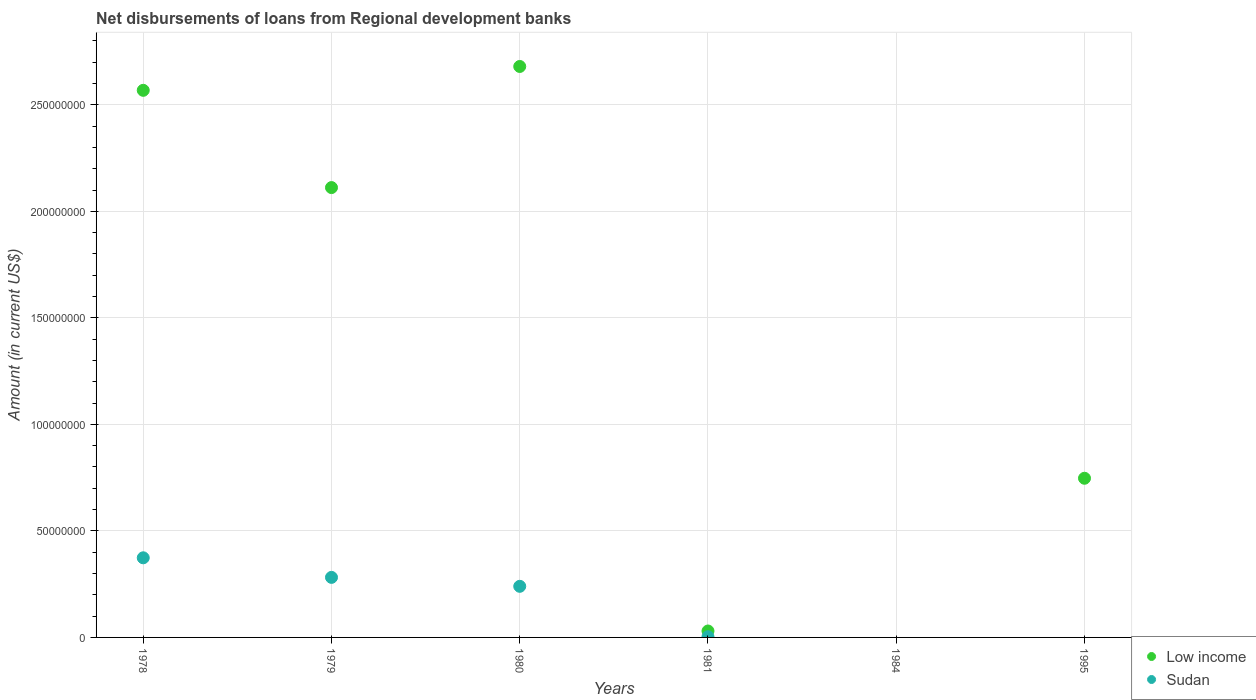What is the amount of disbursements of loans from regional development banks in Sudan in 1979?
Your answer should be very brief. 2.82e+07. Across all years, what is the maximum amount of disbursements of loans from regional development banks in Low income?
Make the answer very short. 2.68e+08. What is the total amount of disbursements of loans from regional development banks in Low income in the graph?
Provide a short and direct response. 8.14e+08. What is the difference between the amount of disbursements of loans from regional development banks in Sudan in 1979 and that in 1981?
Make the answer very short. 2.79e+07. What is the difference between the amount of disbursements of loans from regional development banks in Sudan in 1995 and the amount of disbursements of loans from regional development banks in Low income in 1980?
Provide a short and direct response. -2.68e+08. What is the average amount of disbursements of loans from regional development banks in Sudan per year?
Your answer should be compact. 1.50e+07. In the year 1981, what is the difference between the amount of disbursements of loans from regional development banks in Low income and amount of disbursements of loans from regional development banks in Sudan?
Offer a terse response. 2.70e+06. What is the ratio of the amount of disbursements of loans from regional development banks in Low income in 1979 to that in 1995?
Offer a very short reply. 2.83. What is the difference between the highest and the second highest amount of disbursements of loans from regional development banks in Low income?
Make the answer very short. 1.12e+07. What is the difference between the highest and the lowest amount of disbursements of loans from regional development banks in Sudan?
Make the answer very short. 3.74e+07. How many dotlines are there?
Your answer should be compact. 2. How many years are there in the graph?
Provide a short and direct response. 6. What is the difference between two consecutive major ticks on the Y-axis?
Ensure brevity in your answer.  5.00e+07. Does the graph contain any zero values?
Offer a very short reply. Yes. Does the graph contain grids?
Keep it short and to the point. Yes. Where does the legend appear in the graph?
Provide a succinct answer. Bottom right. How many legend labels are there?
Provide a succinct answer. 2. What is the title of the graph?
Offer a very short reply. Net disbursements of loans from Regional development banks. What is the label or title of the X-axis?
Offer a terse response. Years. What is the label or title of the Y-axis?
Your answer should be very brief. Amount (in current US$). What is the Amount (in current US$) in Low income in 1978?
Keep it short and to the point. 2.57e+08. What is the Amount (in current US$) in Sudan in 1978?
Your answer should be compact. 3.74e+07. What is the Amount (in current US$) in Low income in 1979?
Your answer should be very brief. 2.11e+08. What is the Amount (in current US$) in Sudan in 1979?
Provide a short and direct response. 2.82e+07. What is the Amount (in current US$) in Low income in 1980?
Provide a short and direct response. 2.68e+08. What is the Amount (in current US$) in Sudan in 1980?
Provide a short and direct response. 2.40e+07. What is the Amount (in current US$) of Low income in 1981?
Give a very brief answer. 3.02e+06. What is the Amount (in current US$) of Sudan in 1981?
Offer a terse response. 3.20e+05. What is the Amount (in current US$) in Low income in 1984?
Your response must be concise. 0. What is the Amount (in current US$) of Low income in 1995?
Your response must be concise. 7.47e+07. What is the Amount (in current US$) in Sudan in 1995?
Keep it short and to the point. 0. Across all years, what is the maximum Amount (in current US$) in Low income?
Offer a terse response. 2.68e+08. Across all years, what is the maximum Amount (in current US$) of Sudan?
Make the answer very short. 3.74e+07. Across all years, what is the minimum Amount (in current US$) of Low income?
Your answer should be very brief. 0. What is the total Amount (in current US$) of Low income in the graph?
Offer a very short reply. 8.14e+08. What is the total Amount (in current US$) in Sudan in the graph?
Offer a very short reply. 8.99e+07. What is the difference between the Amount (in current US$) of Low income in 1978 and that in 1979?
Give a very brief answer. 4.57e+07. What is the difference between the Amount (in current US$) in Sudan in 1978 and that in 1979?
Give a very brief answer. 9.19e+06. What is the difference between the Amount (in current US$) of Low income in 1978 and that in 1980?
Offer a terse response. -1.12e+07. What is the difference between the Amount (in current US$) in Sudan in 1978 and that in 1980?
Provide a short and direct response. 1.34e+07. What is the difference between the Amount (in current US$) of Low income in 1978 and that in 1981?
Make the answer very short. 2.54e+08. What is the difference between the Amount (in current US$) in Sudan in 1978 and that in 1981?
Ensure brevity in your answer.  3.71e+07. What is the difference between the Amount (in current US$) in Low income in 1978 and that in 1995?
Make the answer very short. 1.82e+08. What is the difference between the Amount (in current US$) in Low income in 1979 and that in 1980?
Make the answer very short. -5.68e+07. What is the difference between the Amount (in current US$) in Sudan in 1979 and that in 1980?
Ensure brevity in your answer.  4.20e+06. What is the difference between the Amount (in current US$) in Low income in 1979 and that in 1981?
Make the answer very short. 2.08e+08. What is the difference between the Amount (in current US$) of Sudan in 1979 and that in 1981?
Your response must be concise. 2.79e+07. What is the difference between the Amount (in current US$) of Low income in 1979 and that in 1995?
Your answer should be compact. 1.36e+08. What is the difference between the Amount (in current US$) of Low income in 1980 and that in 1981?
Offer a very short reply. 2.65e+08. What is the difference between the Amount (in current US$) in Sudan in 1980 and that in 1981?
Offer a terse response. 2.37e+07. What is the difference between the Amount (in current US$) in Low income in 1980 and that in 1995?
Make the answer very short. 1.93e+08. What is the difference between the Amount (in current US$) of Low income in 1981 and that in 1995?
Make the answer very short. -7.17e+07. What is the difference between the Amount (in current US$) of Low income in 1978 and the Amount (in current US$) of Sudan in 1979?
Ensure brevity in your answer.  2.29e+08. What is the difference between the Amount (in current US$) of Low income in 1978 and the Amount (in current US$) of Sudan in 1980?
Ensure brevity in your answer.  2.33e+08. What is the difference between the Amount (in current US$) of Low income in 1978 and the Amount (in current US$) of Sudan in 1981?
Provide a succinct answer. 2.56e+08. What is the difference between the Amount (in current US$) of Low income in 1979 and the Amount (in current US$) of Sudan in 1980?
Your answer should be very brief. 1.87e+08. What is the difference between the Amount (in current US$) of Low income in 1979 and the Amount (in current US$) of Sudan in 1981?
Your response must be concise. 2.11e+08. What is the difference between the Amount (in current US$) in Low income in 1980 and the Amount (in current US$) in Sudan in 1981?
Your response must be concise. 2.68e+08. What is the average Amount (in current US$) in Low income per year?
Your answer should be compact. 1.36e+08. What is the average Amount (in current US$) in Sudan per year?
Provide a short and direct response. 1.50e+07. In the year 1978, what is the difference between the Amount (in current US$) in Low income and Amount (in current US$) in Sudan?
Give a very brief answer. 2.19e+08. In the year 1979, what is the difference between the Amount (in current US$) of Low income and Amount (in current US$) of Sudan?
Ensure brevity in your answer.  1.83e+08. In the year 1980, what is the difference between the Amount (in current US$) of Low income and Amount (in current US$) of Sudan?
Ensure brevity in your answer.  2.44e+08. In the year 1981, what is the difference between the Amount (in current US$) in Low income and Amount (in current US$) in Sudan?
Give a very brief answer. 2.70e+06. What is the ratio of the Amount (in current US$) in Low income in 1978 to that in 1979?
Give a very brief answer. 1.22. What is the ratio of the Amount (in current US$) of Sudan in 1978 to that in 1979?
Your answer should be very brief. 1.33. What is the ratio of the Amount (in current US$) of Low income in 1978 to that in 1980?
Keep it short and to the point. 0.96. What is the ratio of the Amount (in current US$) in Sudan in 1978 to that in 1980?
Your response must be concise. 1.56. What is the ratio of the Amount (in current US$) of Low income in 1978 to that in 1981?
Provide a succinct answer. 85.12. What is the ratio of the Amount (in current US$) in Sudan in 1978 to that in 1981?
Provide a succinct answer. 116.79. What is the ratio of the Amount (in current US$) of Low income in 1978 to that in 1995?
Your answer should be compact. 3.44. What is the ratio of the Amount (in current US$) in Low income in 1979 to that in 1980?
Make the answer very short. 0.79. What is the ratio of the Amount (in current US$) of Sudan in 1979 to that in 1980?
Your answer should be very brief. 1.17. What is the ratio of the Amount (in current US$) in Low income in 1979 to that in 1981?
Your response must be concise. 69.99. What is the ratio of the Amount (in current US$) in Sudan in 1979 to that in 1981?
Give a very brief answer. 88.08. What is the ratio of the Amount (in current US$) of Low income in 1979 to that in 1995?
Ensure brevity in your answer.  2.83. What is the ratio of the Amount (in current US$) of Low income in 1980 to that in 1981?
Your response must be concise. 88.83. What is the ratio of the Amount (in current US$) in Sudan in 1980 to that in 1981?
Keep it short and to the point. 74.97. What is the ratio of the Amount (in current US$) of Low income in 1980 to that in 1995?
Make the answer very short. 3.59. What is the ratio of the Amount (in current US$) of Low income in 1981 to that in 1995?
Offer a terse response. 0.04. What is the difference between the highest and the second highest Amount (in current US$) of Low income?
Offer a terse response. 1.12e+07. What is the difference between the highest and the second highest Amount (in current US$) in Sudan?
Provide a short and direct response. 9.19e+06. What is the difference between the highest and the lowest Amount (in current US$) of Low income?
Offer a terse response. 2.68e+08. What is the difference between the highest and the lowest Amount (in current US$) in Sudan?
Offer a very short reply. 3.74e+07. 